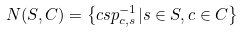Convert formula to latex. <formula><loc_0><loc_0><loc_500><loc_500>N ( S , C ) = \left \{ c s p _ { c , s } ^ { - 1 } | s \in S , c \in C \right \}</formula> 